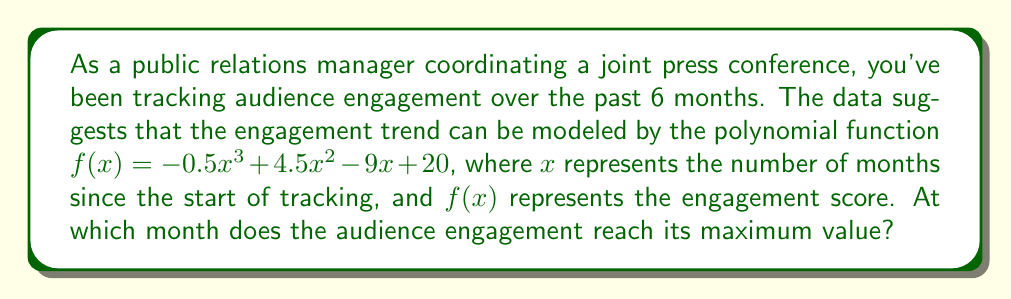Solve this math problem. To find the month when audience engagement reaches its maximum value, we need to follow these steps:

1) First, we need to find the derivative of the function $f(x)$:
   $$f'(x) = -1.5x^2 + 9x - 9$$

2) The maximum point occurs where the derivative equals zero. So, let's set $f'(x) = 0$:
   $$-1.5x^2 + 9x - 9 = 0$$

3) This is a quadratic equation. We can solve it using the quadratic formula:
   $$x = \frac{-b \pm \sqrt{b^2 - 4ac}}{2a}$$
   where $a = -1.5$, $b = 9$, and $c = -9$

4) Plugging in these values:
   $$x = \frac{-9 \pm \sqrt{9^2 - 4(-1.5)(-9)}}{2(-1.5)}$$
   $$= \frac{-9 \pm \sqrt{81 - 54}}{-3}$$
   $$= \frac{-9 \pm \sqrt{27}}{-3}$$
   $$= \frac{-9 \pm 3\sqrt{3}}{-3}$$

5) This gives us two solutions:
   $$x_1 = \frac{-9 + 3\sqrt{3}}{-3} = 3 - \sqrt{3}$$
   $$x_2 = \frac{-9 - 3\sqrt{3}}{-3} = 3 + \sqrt{3}$$

6) Since we're looking for a maximum point, and the leading coefficient of our original function is negative ($-0.5x^3$), the smaller value will give us the maximum.

7) Therefore, the maximum occurs at $x = 3 - \sqrt{3} \approx 1.27$ months.

8) Since we're dealing with whole months in this context, we round to the nearest month, which is 1.
Answer: 1 month 